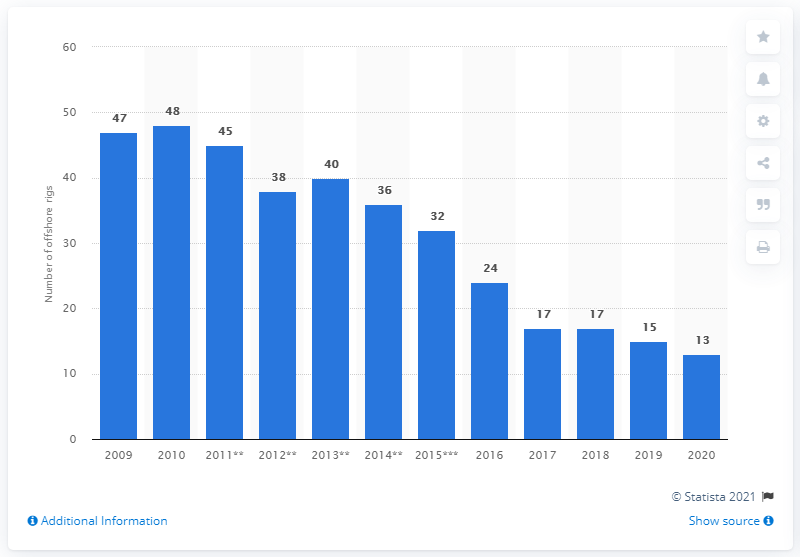Outline some significant characteristics in this image. In the year 2010, there were 48 drilling rigs that were operational. Diamond Offshore Drilling operated 13 drilling rigs in 2020. 